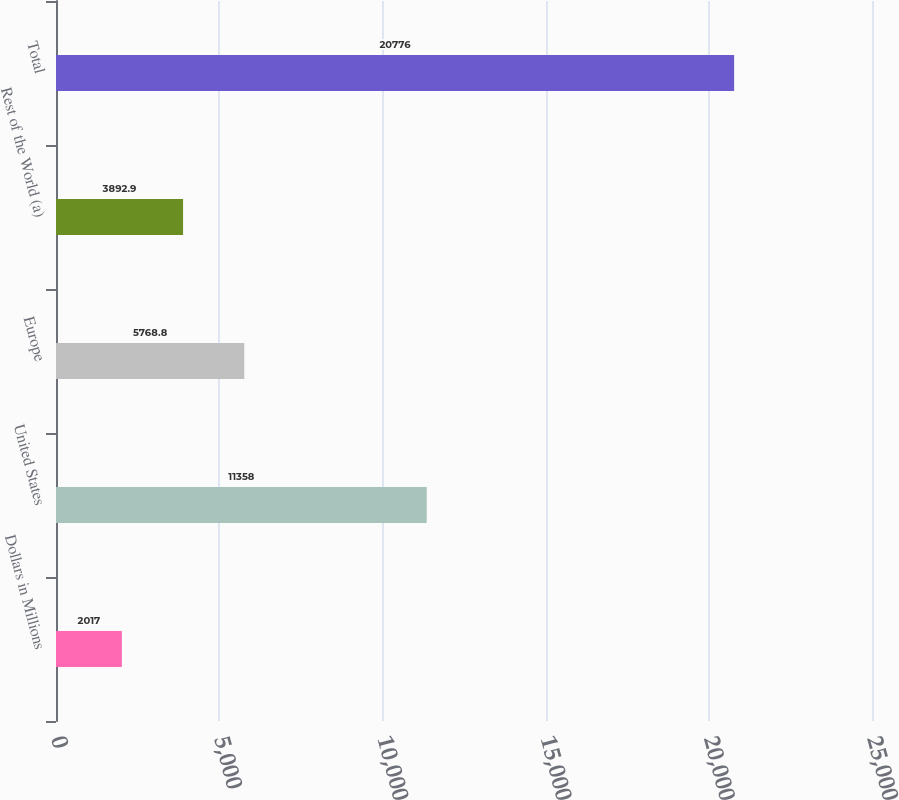<chart> <loc_0><loc_0><loc_500><loc_500><bar_chart><fcel>Dollars in Millions<fcel>United States<fcel>Europe<fcel>Rest of the World (a)<fcel>Total<nl><fcel>2017<fcel>11358<fcel>5768.8<fcel>3892.9<fcel>20776<nl></chart> 